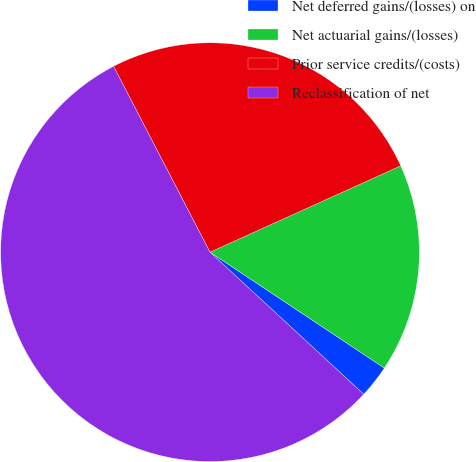Convert chart to OTSL. <chart><loc_0><loc_0><loc_500><loc_500><pie_chart><fcel>Net deferred gains/(losses) on<fcel>Net actuarial gains/(losses)<fcel>Prior service credits/(costs)<fcel>Reclassification of net<nl><fcel>2.54%<fcel>16.1%<fcel>25.85%<fcel>55.51%<nl></chart> 